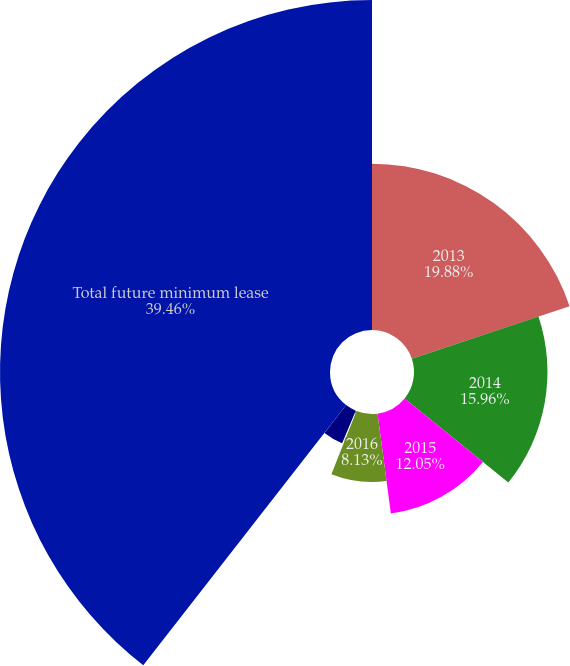<chart> <loc_0><loc_0><loc_500><loc_500><pie_chart><fcel>2013<fcel>2014<fcel>2015<fcel>2016<fcel>2017<fcel>Thereafter<fcel>Total future minimum lease<nl><fcel>19.88%<fcel>15.96%<fcel>12.05%<fcel>8.13%<fcel>0.3%<fcel>4.22%<fcel>39.46%<nl></chart> 